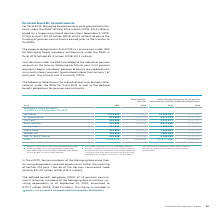According to Siemens Ag's financial document, What was the expense recognized in fiscal 2019 as a service cost under IFRS for Managing Board members’ entitlements amount to? According to the financial document, € 5.6 million. The relevant text states: "e granted contribu - tions under the BSAV totaling € 5.6 million (2018: € 5.4 million), based on a Supervisory Board decision from November 7, 2019. Of this amount,..." Also, What is the current interest rate? Based on the financial document, the answer is 0.90%. Also, What was The defined benefit obligation (DBO) of all pension commitments to former members of the Managing Board and their surviving dependents as of September 30, 2019 amount to? Based on the financial document, the answer is €175.7 million. Also, can you calculate: What was the increase in Joe Kaeser salary from 2018 to 2019? Based on the calculation: 1,234,800 - 1,210,440, the result is 24360 (in millions). This is based on the information: "Joe Kaeser 1,234,800 1,210,440 14,299,267 12,970,960 Joe Kaeser 1,234,800 1,210,440 14,299,267 12,970,960..." The key data points involved are: 1,210,440, 1,234,800. Also, can you calculate: What is the percentage increase / (decrease) of Cedrik Neike's salary from 2018 to 2019? To answer this question, I need to perform calculations using the financial data. The calculation is: 616,896 / 604,800 - 1, which equals 2 (percentage). This is based on the information: "Dr. Roland Busch 616,896 604,800 6,071,233 5,121,226 Dr. Roland Busch 616,896 604,800 6,071,233 5,121,226..." The key data points involved are: 604,800, 616,896. Also, can you calculate: What percentage of total compensation was Michael Sen's salary? Based on the calculation: 616,896 / 5,553,072, the result is 11.11 (percentage). This is based on the information: "Total 5,553,072 5,444,040 45,617,700 39,518,836 Dr. Roland Busch 616,896 604,800 6,071,233 5,121,226..." The key data points involved are: 5,553,072, 616,896. 